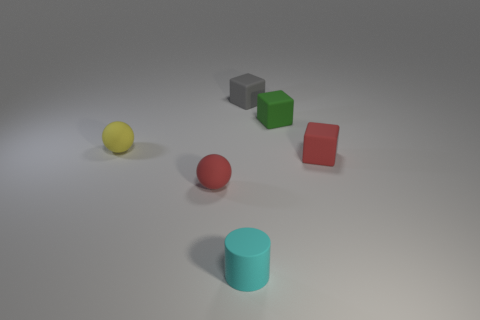Subtract all brown cubes. Subtract all red cylinders. How many cubes are left? 3 Add 3 tiny metallic blocks. How many objects exist? 9 Subtract all balls. How many objects are left? 4 Subtract 0 green balls. How many objects are left? 6 Subtract all purple things. Subtract all tiny cyan rubber cylinders. How many objects are left? 5 Add 4 cyan rubber cylinders. How many cyan rubber cylinders are left? 5 Add 4 cyan matte objects. How many cyan matte objects exist? 5 